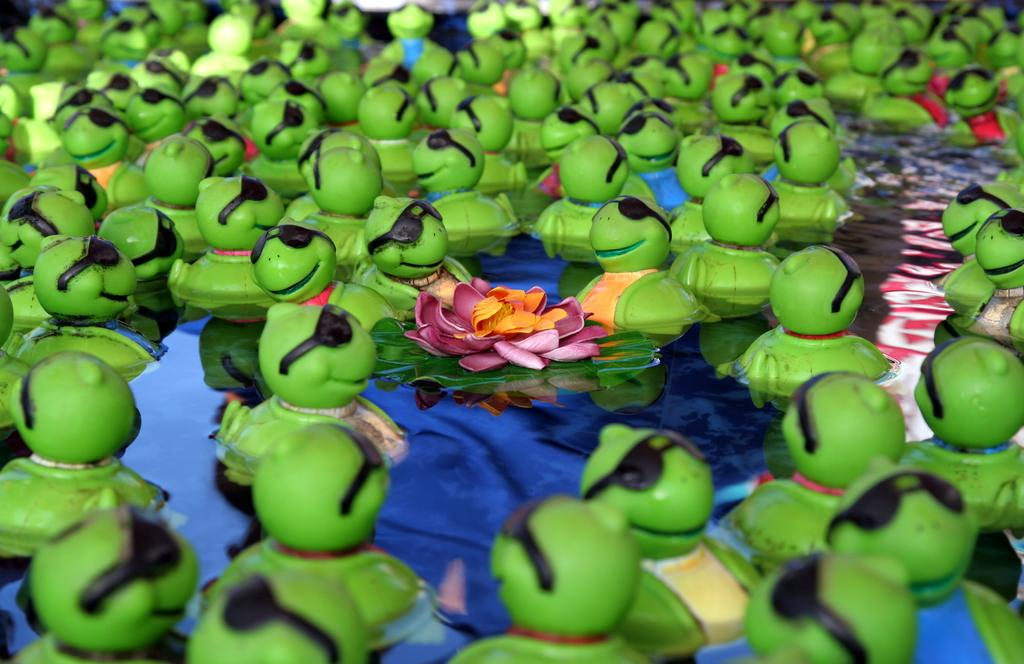What objects are in the water in the foreground of the image? There are green toys in the water in the foreground of the image. What type of decoration is on the water? There is an artificial flower on the water. What other natural object is on the water? There is a leaf on the water. Where is the bag located in the image? There is no bag present in the image. Can you see a kitty playing with the artificial flower in the image? There is no kitty present in the image. 